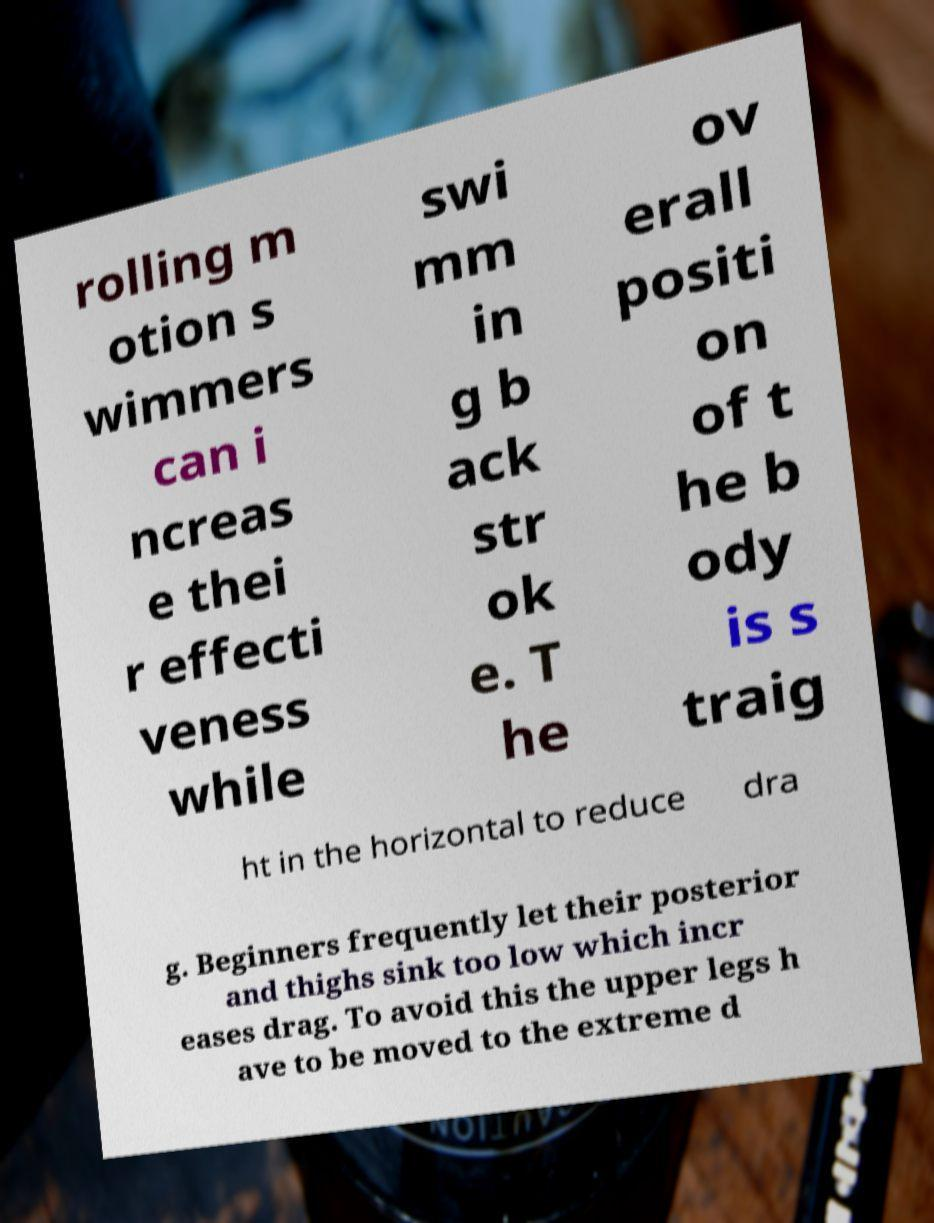Can you accurately transcribe the text from the provided image for me? rolling m otion s wimmers can i ncreas e thei r effecti veness while swi mm in g b ack str ok e. T he ov erall positi on of t he b ody is s traig ht in the horizontal to reduce dra g. Beginners frequently let their posterior and thighs sink too low which incr eases drag. To avoid this the upper legs h ave to be moved to the extreme d 